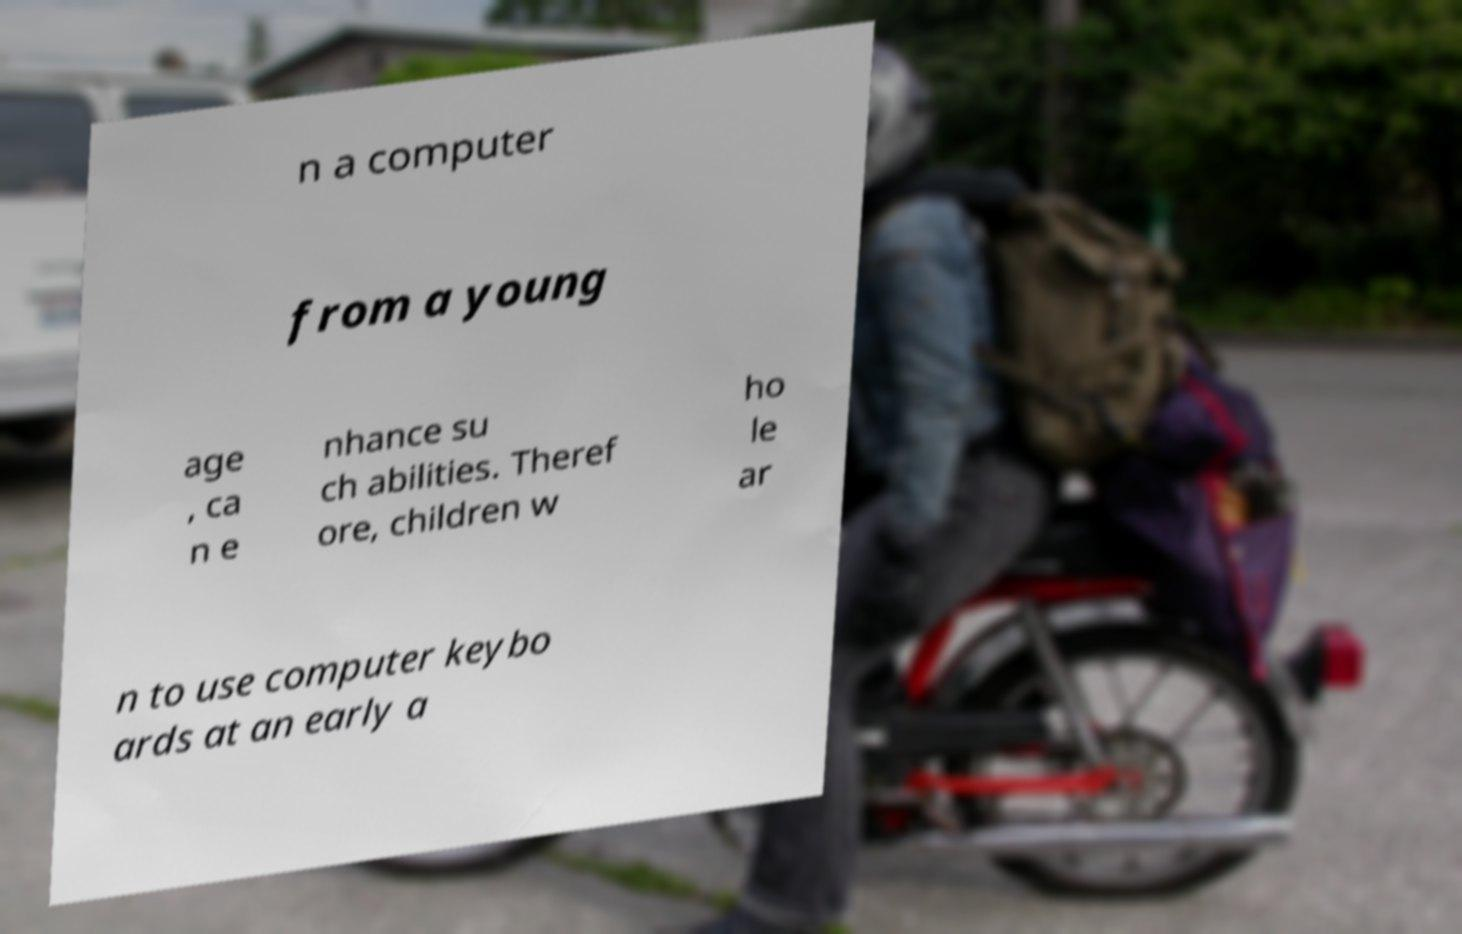Can you accurately transcribe the text from the provided image for me? n a computer from a young age , ca n e nhance su ch abilities. Theref ore, children w ho le ar n to use computer keybo ards at an early a 